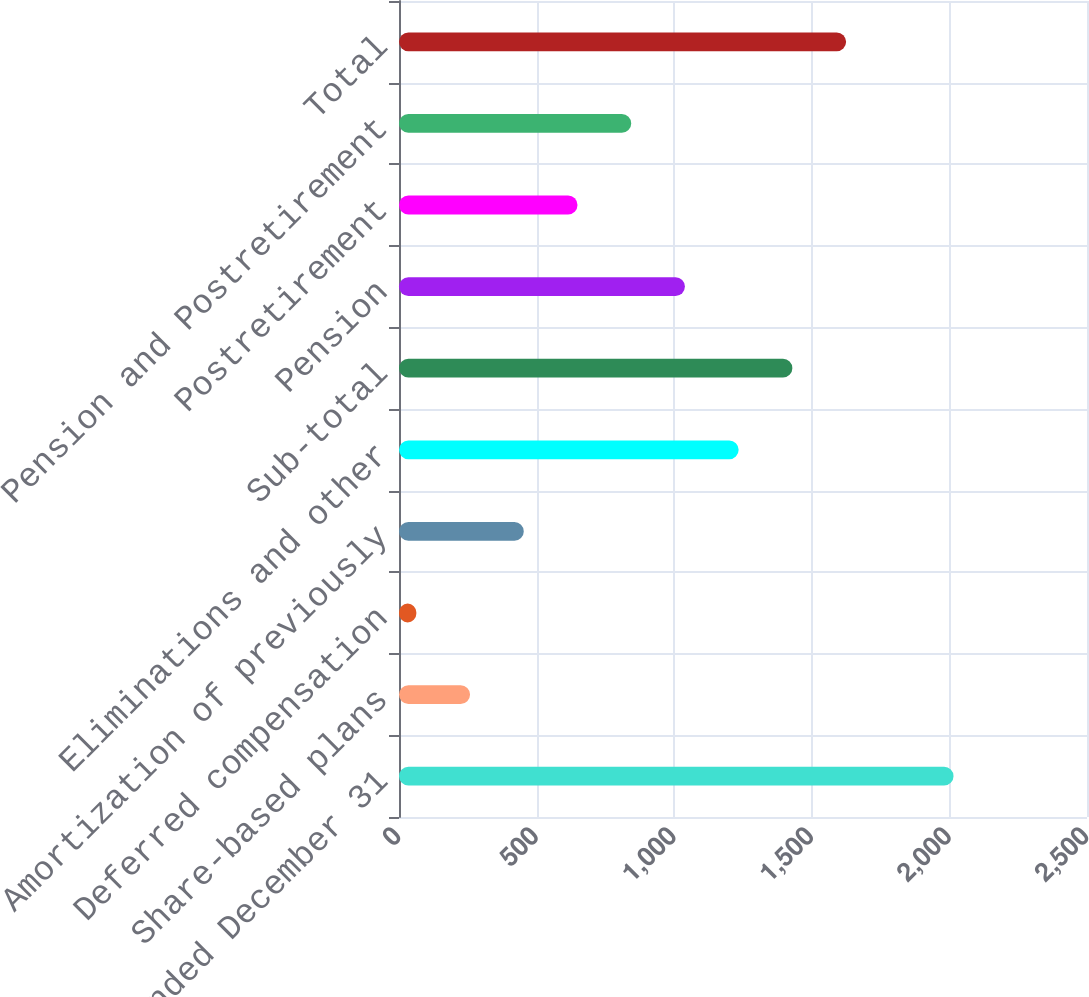Convert chart to OTSL. <chart><loc_0><loc_0><loc_500><loc_500><bar_chart><fcel>Years ended December 31<fcel>Share-based plans<fcel>Deferred compensation<fcel>Amortization of previously<fcel>Eliminations and other<fcel>Sub-total<fcel>Pension<fcel>Postretirement<fcel>Pension and Postretirement<fcel>Total<nl><fcel>2015<fcel>258.2<fcel>63<fcel>453.4<fcel>1234.2<fcel>1429.4<fcel>1039<fcel>648.6<fcel>843.8<fcel>1624.6<nl></chart> 